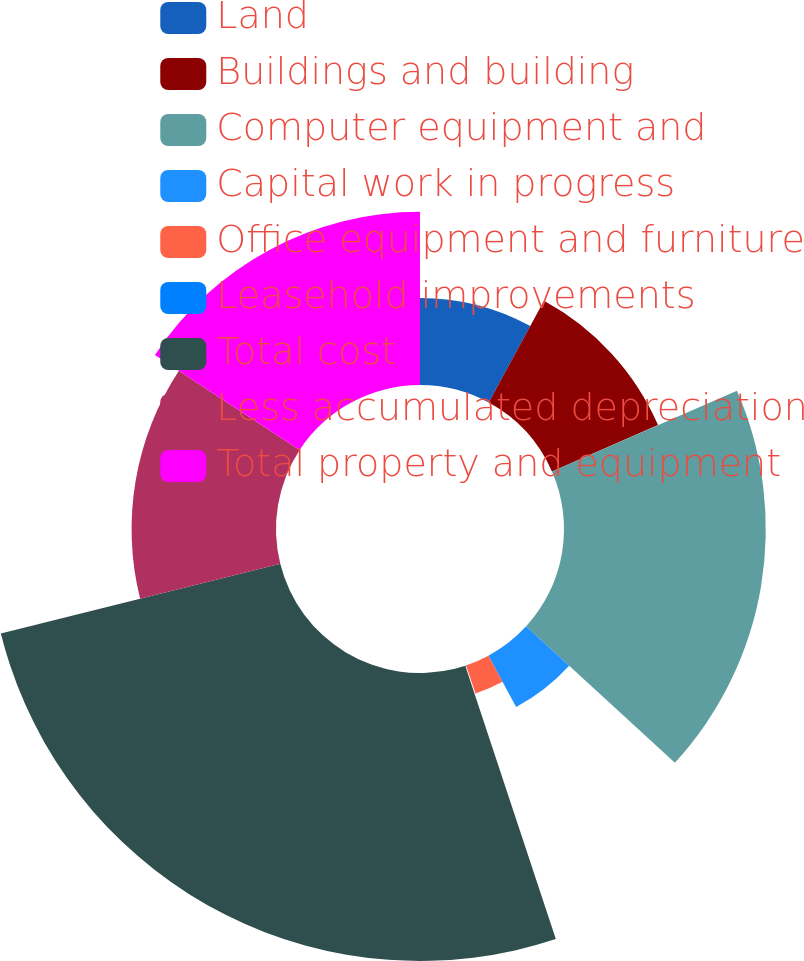Convert chart to OTSL. <chart><loc_0><loc_0><loc_500><loc_500><pie_chart><fcel>Land<fcel>Buildings and building<fcel>Computer equipment and<fcel>Capital work in progress<fcel>Office equipment and furniture<fcel>Leasehold improvements<fcel>Total cost<fcel>Less accumulated depreciation<fcel>Total property and equipment<nl><fcel>7.92%<fcel>10.53%<fcel>18.36%<fcel>5.31%<fcel>2.7%<fcel>0.09%<fcel>26.2%<fcel>13.14%<fcel>15.75%<nl></chart> 